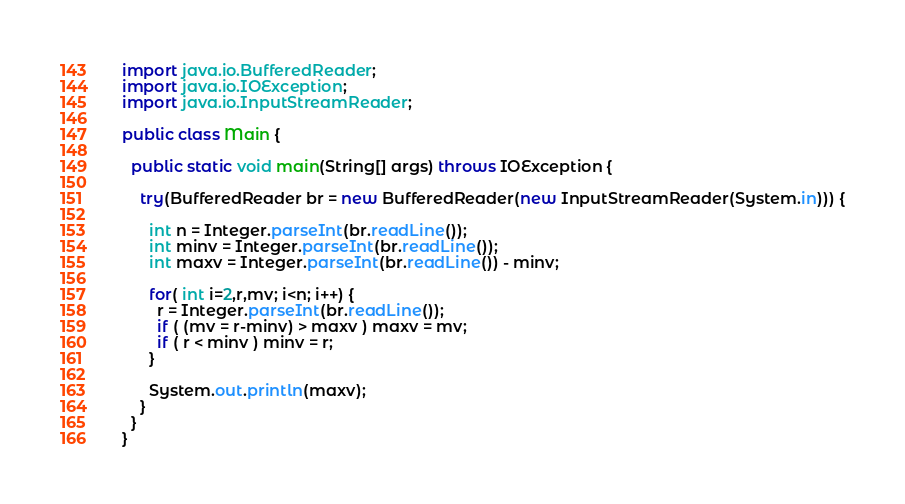<code> <loc_0><loc_0><loc_500><loc_500><_Java_>import java.io.BufferedReader;
import java.io.IOException;
import java.io.InputStreamReader;

public class Main {

  public static void main(String[] args) throws IOException {
    
    try(BufferedReader br = new BufferedReader(new InputStreamReader(System.in))) {

      int n = Integer.parseInt(br.readLine());
      int minv = Integer.parseInt(br.readLine());
      int maxv = Integer.parseInt(br.readLine()) - minv;

      for( int i=2,r,mv; i<n; i++) {
        r = Integer.parseInt(br.readLine());
        if ( (mv = r-minv) > maxv ) maxv = mv;
        if ( r < minv ) minv = r; 
      }

      System.out.println(maxv);
    }
  }
}
</code> 